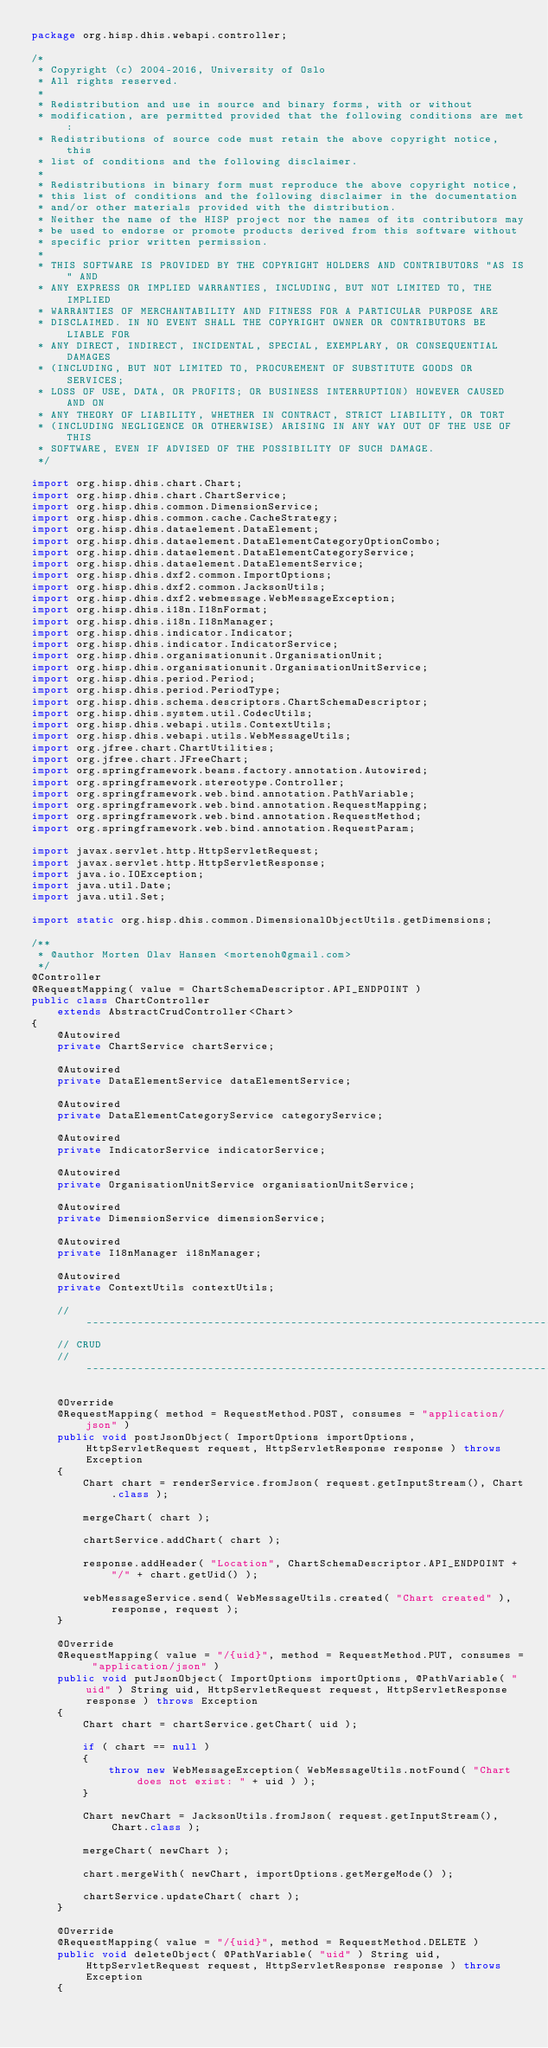<code> <loc_0><loc_0><loc_500><loc_500><_Java_>package org.hisp.dhis.webapi.controller;

/*
 * Copyright (c) 2004-2016, University of Oslo
 * All rights reserved.
 *
 * Redistribution and use in source and binary forms, with or without
 * modification, are permitted provided that the following conditions are met:
 * Redistributions of source code must retain the above copyright notice, this
 * list of conditions and the following disclaimer.
 *
 * Redistributions in binary form must reproduce the above copyright notice,
 * this list of conditions and the following disclaimer in the documentation
 * and/or other materials provided with the distribution.
 * Neither the name of the HISP project nor the names of its contributors may
 * be used to endorse or promote products derived from this software without
 * specific prior written permission.
 *
 * THIS SOFTWARE IS PROVIDED BY THE COPYRIGHT HOLDERS AND CONTRIBUTORS "AS IS" AND
 * ANY EXPRESS OR IMPLIED WARRANTIES, INCLUDING, BUT NOT LIMITED TO, THE IMPLIED
 * WARRANTIES OF MERCHANTABILITY AND FITNESS FOR A PARTICULAR PURPOSE ARE
 * DISCLAIMED. IN NO EVENT SHALL THE COPYRIGHT OWNER OR CONTRIBUTORS BE LIABLE FOR
 * ANY DIRECT, INDIRECT, INCIDENTAL, SPECIAL, EXEMPLARY, OR CONSEQUENTIAL DAMAGES
 * (INCLUDING, BUT NOT LIMITED TO, PROCUREMENT OF SUBSTITUTE GOODS OR SERVICES;
 * LOSS OF USE, DATA, OR PROFITS; OR BUSINESS INTERRUPTION) HOWEVER CAUSED AND ON
 * ANY THEORY OF LIABILITY, WHETHER IN CONTRACT, STRICT LIABILITY, OR TORT
 * (INCLUDING NEGLIGENCE OR OTHERWISE) ARISING IN ANY WAY OUT OF THE USE OF THIS
 * SOFTWARE, EVEN IF ADVISED OF THE POSSIBILITY OF SUCH DAMAGE.
 */

import org.hisp.dhis.chart.Chart;
import org.hisp.dhis.chart.ChartService;
import org.hisp.dhis.common.DimensionService;
import org.hisp.dhis.common.cache.CacheStrategy;
import org.hisp.dhis.dataelement.DataElement;
import org.hisp.dhis.dataelement.DataElementCategoryOptionCombo;
import org.hisp.dhis.dataelement.DataElementCategoryService;
import org.hisp.dhis.dataelement.DataElementService;
import org.hisp.dhis.dxf2.common.ImportOptions;
import org.hisp.dhis.dxf2.common.JacksonUtils;
import org.hisp.dhis.dxf2.webmessage.WebMessageException;
import org.hisp.dhis.i18n.I18nFormat;
import org.hisp.dhis.i18n.I18nManager;
import org.hisp.dhis.indicator.Indicator;
import org.hisp.dhis.indicator.IndicatorService;
import org.hisp.dhis.organisationunit.OrganisationUnit;
import org.hisp.dhis.organisationunit.OrganisationUnitService;
import org.hisp.dhis.period.Period;
import org.hisp.dhis.period.PeriodType;
import org.hisp.dhis.schema.descriptors.ChartSchemaDescriptor;
import org.hisp.dhis.system.util.CodecUtils;
import org.hisp.dhis.webapi.utils.ContextUtils;
import org.hisp.dhis.webapi.utils.WebMessageUtils;
import org.jfree.chart.ChartUtilities;
import org.jfree.chart.JFreeChart;
import org.springframework.beans.factory.annotation.Autowired;
import org.springframework.stereotype.Controller;
import org.springframework.web.bind.annotation.PathVariable;
import org.springframework.web.bind.annotation.RequestMapping;
import org.springframework.web.bind.annotation.RequestMethod;
import org.springframework.web.bind.annotation.RequestParam;

import javax.servlet.http.HttpServletRequest;
import javax.servlet.http.HttpServletResponse;
import java.io.IOException;
import java.util.Date;
import java.util.Set;

import static org.hisp.dhis.common.DimensionalObjectUtils.getDimensions;

/**
 * @author Morten Olav Hansen <mortenoh@gmail.com>
 */
@Controller
@RequestMapping( value = ChartSchemaDescriptor.API_ENDPOINT )
public class ChartController
    extends AbstractCrudController<Chart>
{
    @Autowired
    private ChartService chartService;

    @Autowired
    private DataElementService dataElementService;

    @Autowired
    private DataElementCategoryService categoryService;

    @Autowired
    private IndicatorService indicatorService;

    @Autowired
    private OrganisationUnitService organisationUnitService;

    @Autowired
    private DimensionService dimensionService;

    @Autowired
    private I18nManager i18nManager;

    @Autowired
    private ContextUtils contextUtils;

    //--------------------------------------------------------------------------
    // CRUD
    //--------------------------------------------------------------------------

    @Override
    @RequestMapping( method = RequestMethod.POST, consumes = "application/json" )
    public void postJsonObject( ImportOptions importOptions, HttpServletRequest request, HttpServletResponse response ) throws Exception
    {
        Chart chart = renderService.fromJson( request.getInputStream(), Chart.class );

        mergeChart( chart );

        chartService.addChart( chart );

        response.addHeader( "Location", ChartSchemaDescriptor.API_ENDPOINT + "/" + chart.getUid() );

        webMessageService.send( WebMessageUtils.created( "Chart created" ), response, request );
    }

    @Override
    @RequestMapping( value = "/{uid}", method = RequestMethod.PUT, consumes = "application/json" )
    public void putJsonObject( ImportOptions importOptions, @PathVariable( "uid" ) String uid, HttpServletRequest request, HttpServletResponse response ) throws Exception
    {
        Chart chart = chartService.getChart( uid );

        if ( chart == null )
        {
            throw new WebMessageException( WebMessageUtils.notFound( "Chart does not exist: " + uid ) );
        }

        Chart newChart = JacksonUtils.fromJson( request.getInputStream(), Chart.class );

        mergeChart( newChart );

        chart.mergeWith( newChart, importOptions.getMergeMode() );

        chartService.updateChart( chart );
    }

    @Override
    @RequestMapping( value = "/{uid}", method = RequestMethod.DELETE )
    public void deleteObject( @PathVariable( "uid" ) String uid, HttpServletRequest request, HttpServletResponse response ) throws Exception
    {</code> 